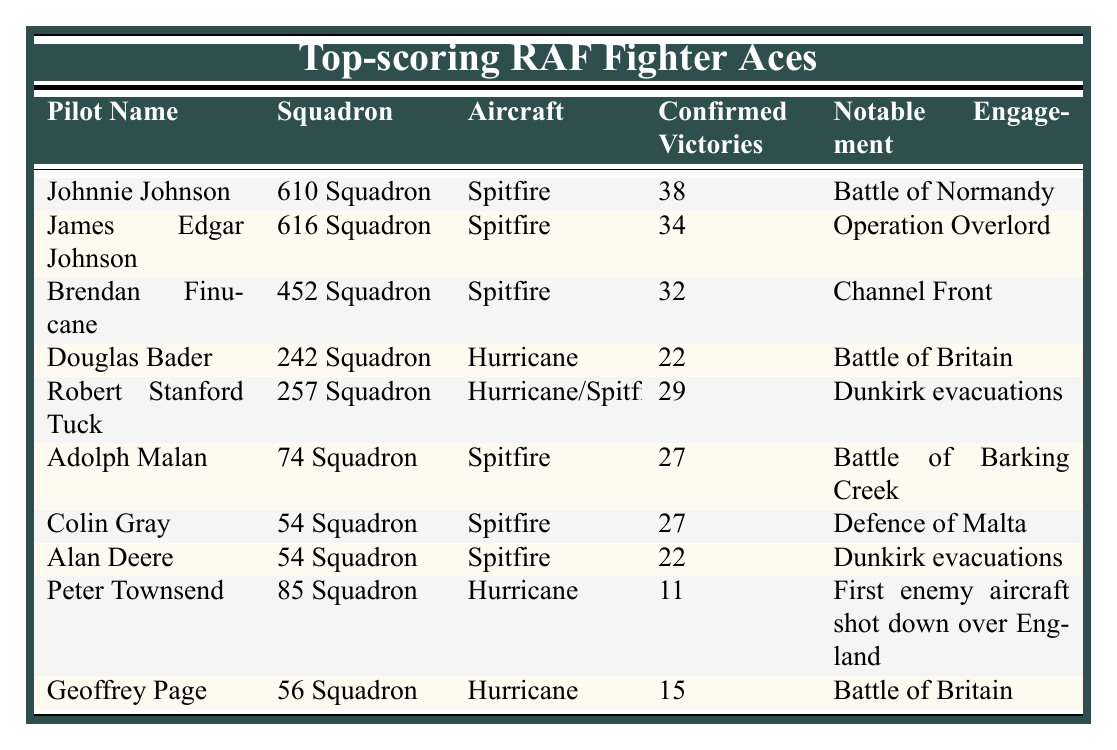What is the name of the pilot with the most confirmed victories? By examining the table, Johnnie Johnson is listed at the top with 38 confirmed victories.
Answer: Johnnie Johnson How many confirmed victories did Douglas Bader achieve? The table states that Douglas Bader had 22 confirmed victories.
Answer: 22 Which aircraft was used by James Edgar Johnson? According to the table, James Edgar Johnson flew the Spitfire.
Answer: Spitfire How many pilots achieved more than 25 confirmed victories? The table shows that Johnnie Johnson, James Edgar Johnson, Brendan Finucane, Robert Stanford Tuck, Adolph Malan, and Colin Gray all had more than 25 confirmed victories, totaling 6 pilots.
Answer: 6 Is there a pilot in the table who achieved exactly 15 confirmed victories? Looking closely, Geoffrey Page is the pilot who achieved exactly 15 confirmed victories as per the table.
Answer: Yes What is the average number of confirmed victories among the pilots listed? First, we sum up all the confirmed victories: 38 + 34 + 32 + 22 + 29 + 27 + 27 + 22 + 11 + 15 =  315. There are 10 pilots, so the average is 315 / 10 = 31.5.
Answer: 31.5 Which squadron had the pilot with the fewest confirmed victories? Upon checking the table, Peter Townsend from 85 Squadron has the fewest confirmed victories at 11.
Answer: 85 Squadron Did any pilot use both the Hurricane and the Spitfire aircraft? Yes, the table indicates that Robert Stanford Tuck used both types, listed as Hurricane/Spitfire.
Answer: Yes What notable engagement is associated with Alan Deere? The notable engagement for Alan Deere is the Dunkirk evacuations, as noted in the table.
Answer: Dunkirk evacuations Who had more confirmed victories, Adolph Malan or Colin Gray? The table indicates both Adolph Malan and Colin Gray had 27 confirmed victories, they are equal.
Answer: Equal 